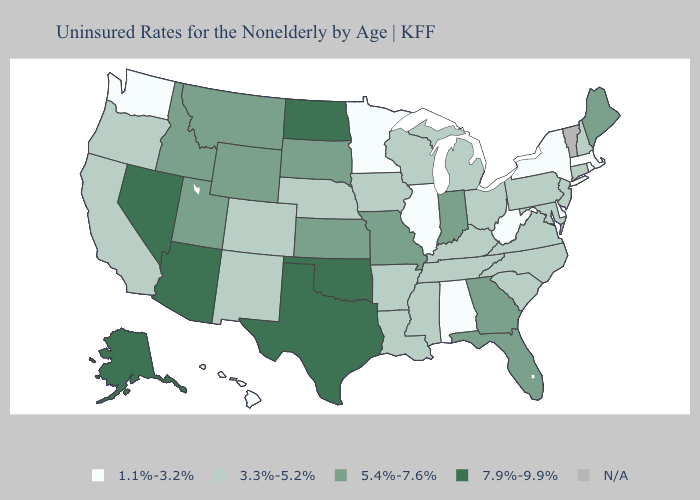Which states have the lowest value in the USA?
Write a very short answer. Alabama, Delaware, Hawaii, Illinois, Massachusetts, Minnesota, New York, Rhode Island, Washington, West Virginia. Name the states that have a value in the range N/A?
Short answer required. Vermont. What is the lowest value in the USA?
Answer briefly. 1.1%-3.2%. Does Alaska have the highest value in the USA?
Write a very short answer. Yes. Name the states that have a value in the range 7.9%-9.9%?
Quick response, please. Alaska, Arizona, Nevada, North Dakota, Oklahoma, Texas. What is the value of Georgia?
Quick response, please. 5.4%-7.6%. Name the states that have a value in the range N/A?
Concise answer only. Vermont. Name the states that have a value in the range 1.1%-3.2%?
Concise answer only. Alabama, Delaware, Hawaii, Illinois, Massachusetts, Minnesota, New York, Rhode Island, Washington, West Virginia. Which states hav the highest value in the South?
Keep it brief. Oklahoma, Texas. Does Washington have the lowest value in the USA?
Be succinct. Yes. Does the first symbol in the legend represent the smallest category?
Quick response, please. Yes. Which states have the lowest value in the USA?
Quick response, please. Alabama, Delaware, Hawaii, Illinois, Massachusetts, Minnesota, New York, Rhode Island, Washington, West Virginia. What is the highest value in the MidWest ?
Give a very brief answer. 7.9%-9.9%. How many symbols are there in the legend?
Give a very brief answer. 5. 